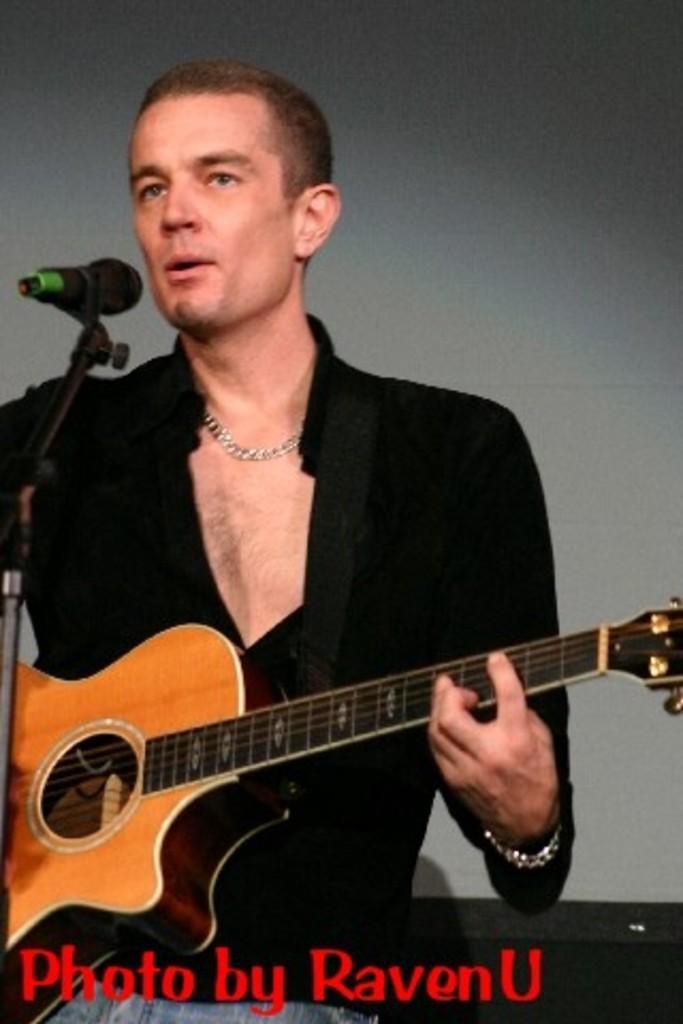Please provide a concise description of this image. This picture is mainly highlighted with a man wearing black colour shirt, standing infront of a mike singing and playing guitar. 